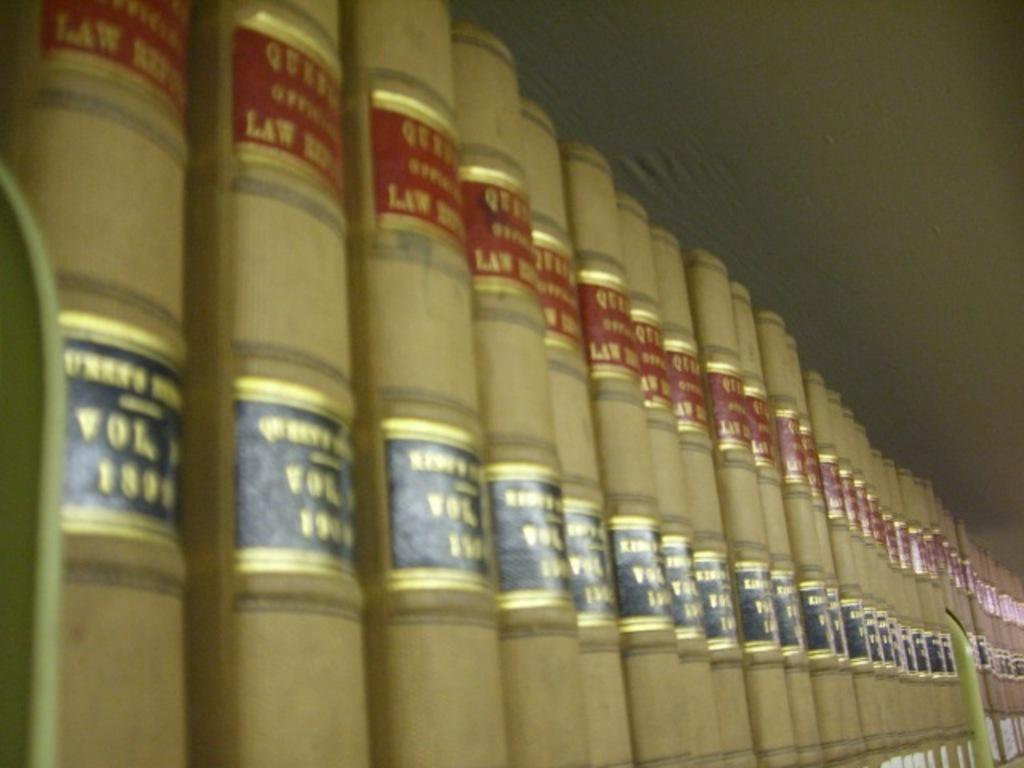<image>
Render a clear and concise summary of the photo. the word law is on the light book 